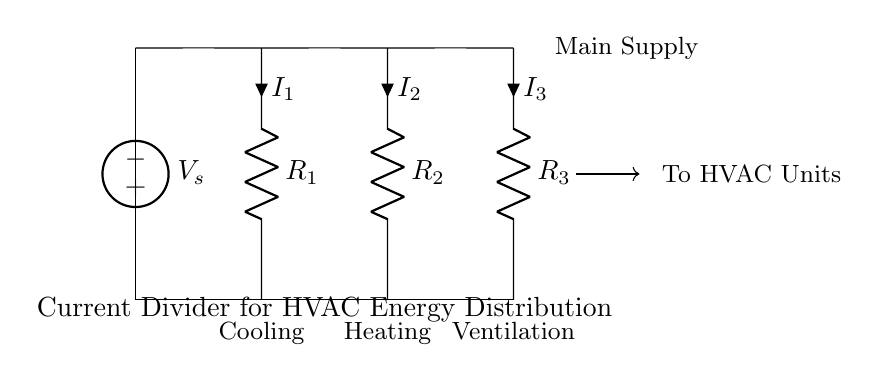What is the total number of resistors in the circuit? The circuit diagram shows three resistors labeled as R1, R2, and R3. Each is connected in parallel configuration. Counting these, we find three resistors total.
Answer: Three What type of circuit is this diagram illustrating? The presence of multiple paths for current flow indicates that this is a current divider circuit. In a current divider, the total current divides into the parallel branches based on their resistances.
Answer: Current divider What is the source voltage of the circuit? The voltage source labeled as V_s provides the supply voltage. It appears at the top of the circuit and is the only voltage source present, but its specific value is not indicated. Assuming it to be a general supply, it will be denoted simply as V_s.
Answer: V_s Which component is used for cooling? Looking at the labels at the bottom of the circuit, the component that receives the current designated for cooling is identified as R1. It is associated with the cooling function of the HVAC system.
Answer: R1 How does the current divide among the resistors? The distribution of current through the resistors R1, R2, and R3 follows the current divider principle, where the current inversely relates to the resistance values. This means that a lower resistance will have a higher current compared to a higher resistance. Hence, the total current I_s will split based on the resistances, calculated as:
I1 = I_s * (R_total/R1), 
I2 = I_s * (R_total/R2), 
I3 = I_s * (R_total/R3). 
However, the specific numeric values would require known resistance values which are not provided in the diagram.
Answer: Inversely proportional to resistance What type of HVAC units are connected at the output? The circuit diagram specifies the types of HVAC functionalities indicated by labels under each resistor: Cooling for R1, Heating for R2, and Ventilation for R3. Each of these corresponds to different HVAC functions supplied by the current.
Answer: Cooling, Heating, Ventilation 